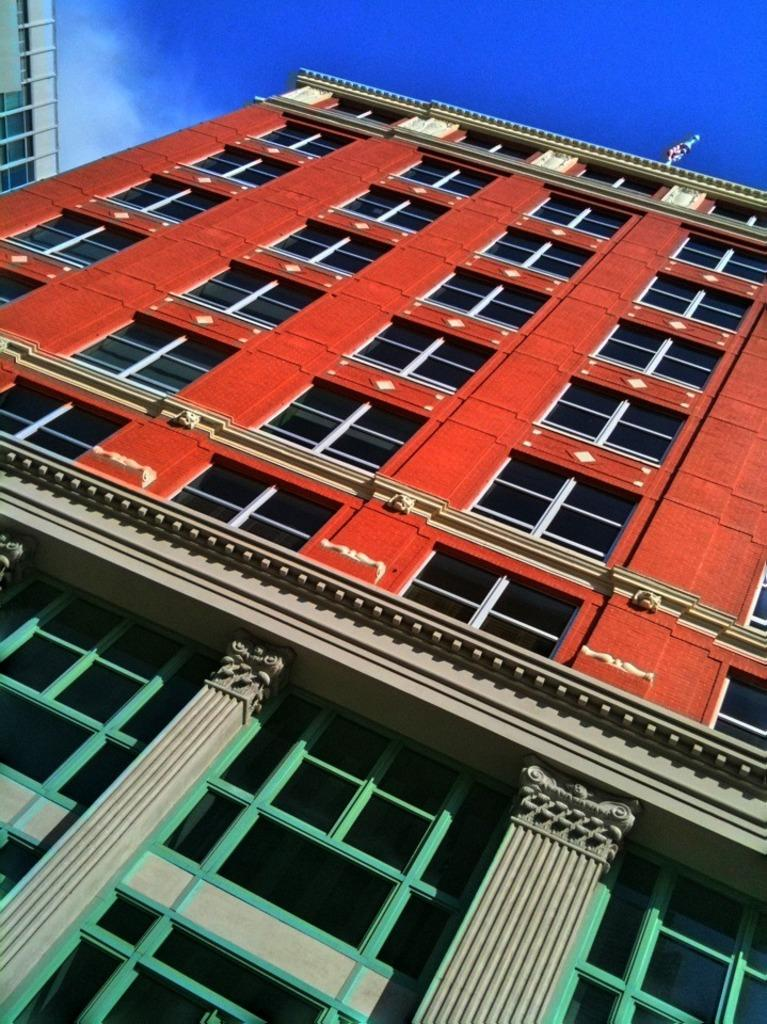What type of structure is present in the image? The image contains a building. What are some features of the building? The building has windows and pillars. Is there any additional architectural element on the building? Yes, there is a pole at the top of the building. What can be seen in the background of the image? The sky is visible in the image. What type of toothpaste is being used to clean the windows of the building in the image? There is no toothpaste present in the image, and the windows are not being cleaned. 